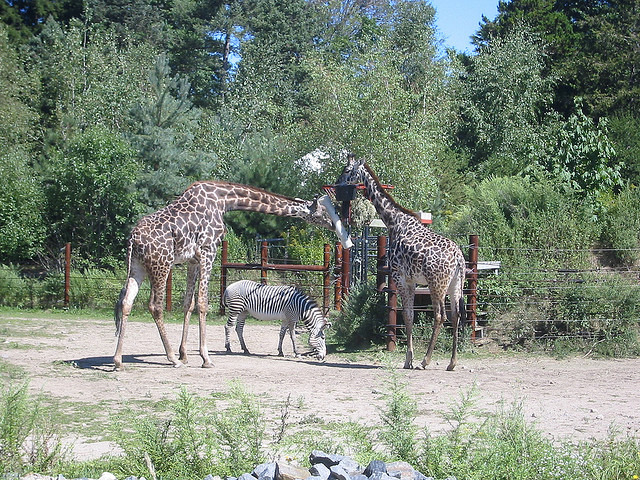What animal is between the giraffes?
A. zebra
B. cow
C. dog
D. cat Nestled between the towering giraffes, we find a zebra. The zebra's striking stripes create a captivating contrast against the dusty backdrop, presenting a quintessential image of wildlife coexistence. 